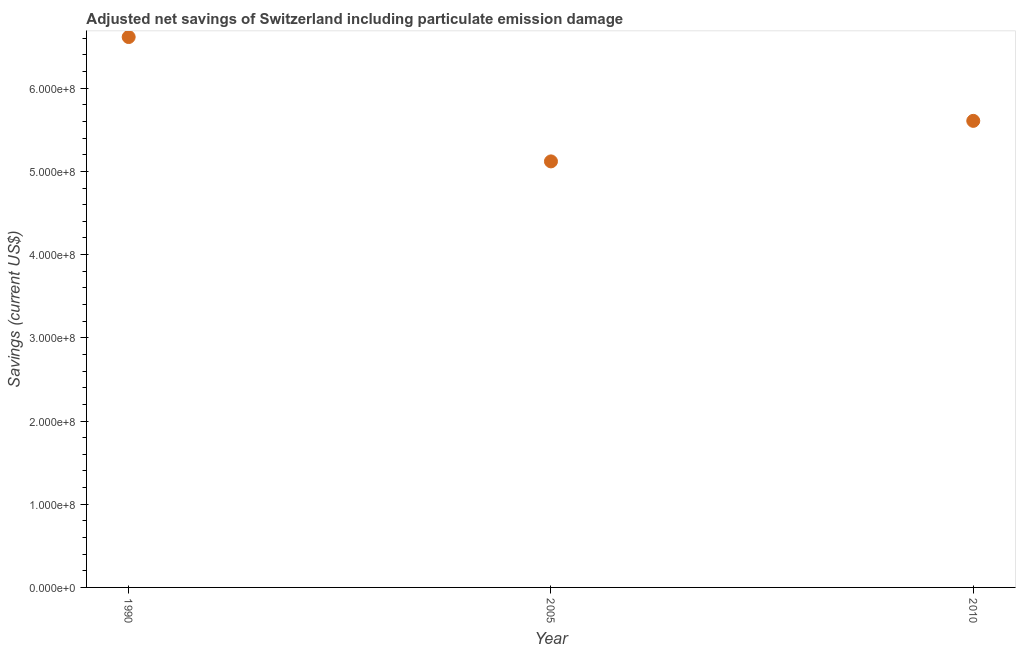What is the adjusted net savings in 2010?
Make the answer very short. 5.61e+08. Across all years, what is the maximum adjusted net savings?
Your answer should be very brief. 6.61e+08. Across all years, what is the minimum adjusted net savings?
Provide a short and direct response. 5.12e+08. In which year was the adjusted net savings maximum?
Provide a short and direct response. 1990. In which year was the adjusted net savings minimum?
Give a very brief answer. 2005. What is the sum of the adjusted net savings?
Offer a terse response. 1.73e+09. What is the difference between the adjusted net savings in 2005 and 2010?
Offer a very short reply. -4.87e+07. What is the average adjusted net savings per year?
Give a very brief answer. 5.78e+08. What is the median adjusted net savings?
Your response must be concise. 5.61e+08. In how many years, is the adjusted net savings greater than 220000000 US$?
Provide a succinct answer. 3. Do a majority of the years between 1990 and 2010 (inclusive) have adjusted net savings greater than 220000000 US$?
Provide a succinct answer. Yes. What is the ratio of the adjusted net savings in 1990 to that in 2005?
Offer a very short reply. 1.29. What is the difference between the highest and the second highest adjusted net savings?
Your response must be concise. 1.01e+08. What is the difference between the highest and the lowest adjusted net savings?
Make the answer very short. 1.49e+08. In how many years, is the adjusted net savings greater than the average adjusted net savings taken over all years?
Offer a terse response. 1. What is the difference between two consecutive major ticks on the Y-axis?
Give a very brief answer. 1.00e+08. Are the values on the major ticks of Y-axis written in scientific E-notation?
Provide a succinct answer. Yes. Does the graph contain any zero values?
Your response must be concise. No. Does the graph contain grids?
Your answer should be very brief. No. What is the title of the graph?
Your response must be concise. Adjusted net savings of Switzerland including particulate emission damage. What is the label or title of the Y-axis?
Make the answer very short. Savings (current US$). What is the Savings (current US$) in 1990?
Provide a succinct answer. 6.61e+08. What is the Savings (current US$) in 2005?
Your answer should be compact. 5.12e+08. What is the Savings (current US$) in 2010?
Your response must be concise. 5.61e+08. What is the difference between the Savings (current US$) in 1990 and 2005?
Give a very brief answer. 1.49e+08. What is the difference between the Savings (current US$) in 1990 and 2010?
Your answer should be very brief. 1.01e+08. What is the difference between the Savings (current US$) in 2005 and 2010?
Your answer should be very brief. -4.87e+07. What is the ratio of the Savings (current US$) in 1990 to that in 2005?
Give a very brief answer. 1.29. What is the ratio of the Savings (current US$) in 1990 to that in 2010?
Offer a very short reply. 1.18. What is the ratio of the Savings (current US$) in 2005 to that in 2010?
Your response must be concise. 0.91. 